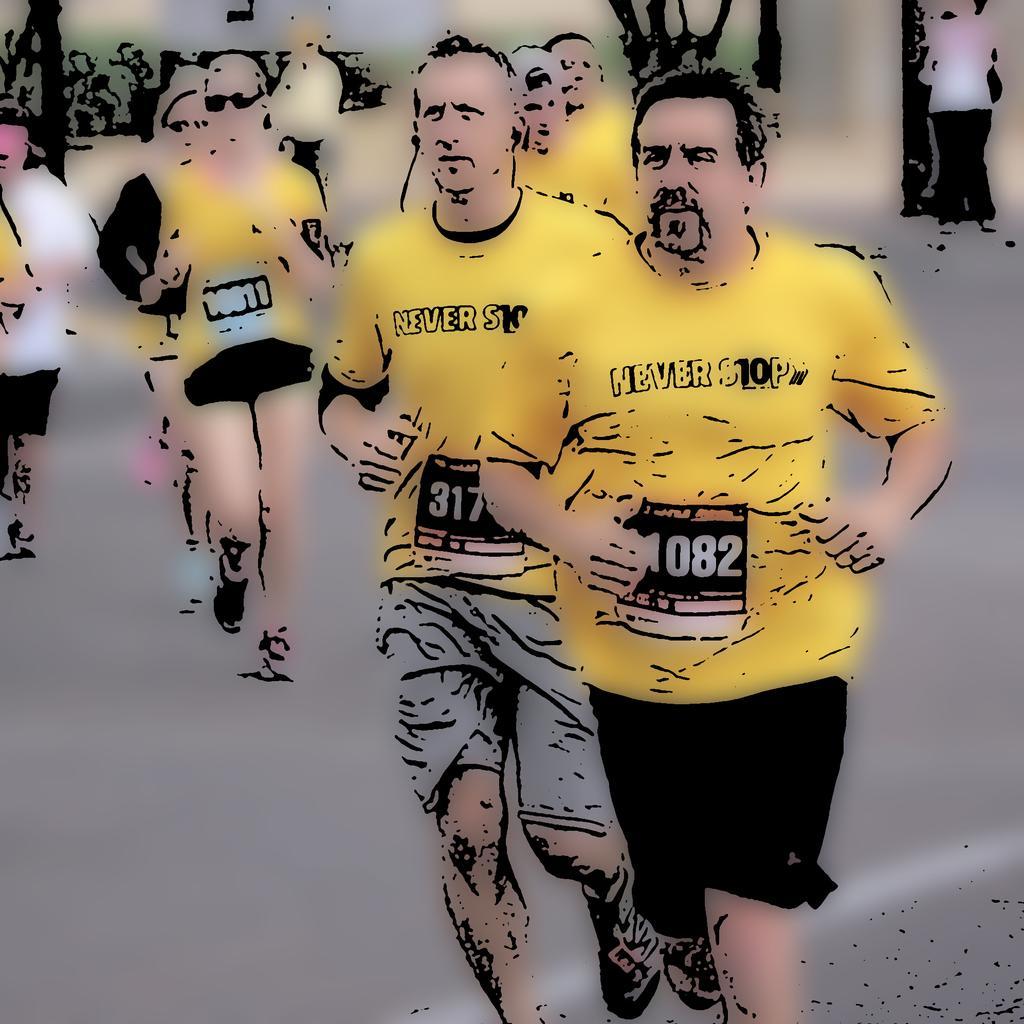How would you summarize this image in a sentence or two? In this image I can see the group of people running on the road. These people are wearing the yellow and black color dresses. 